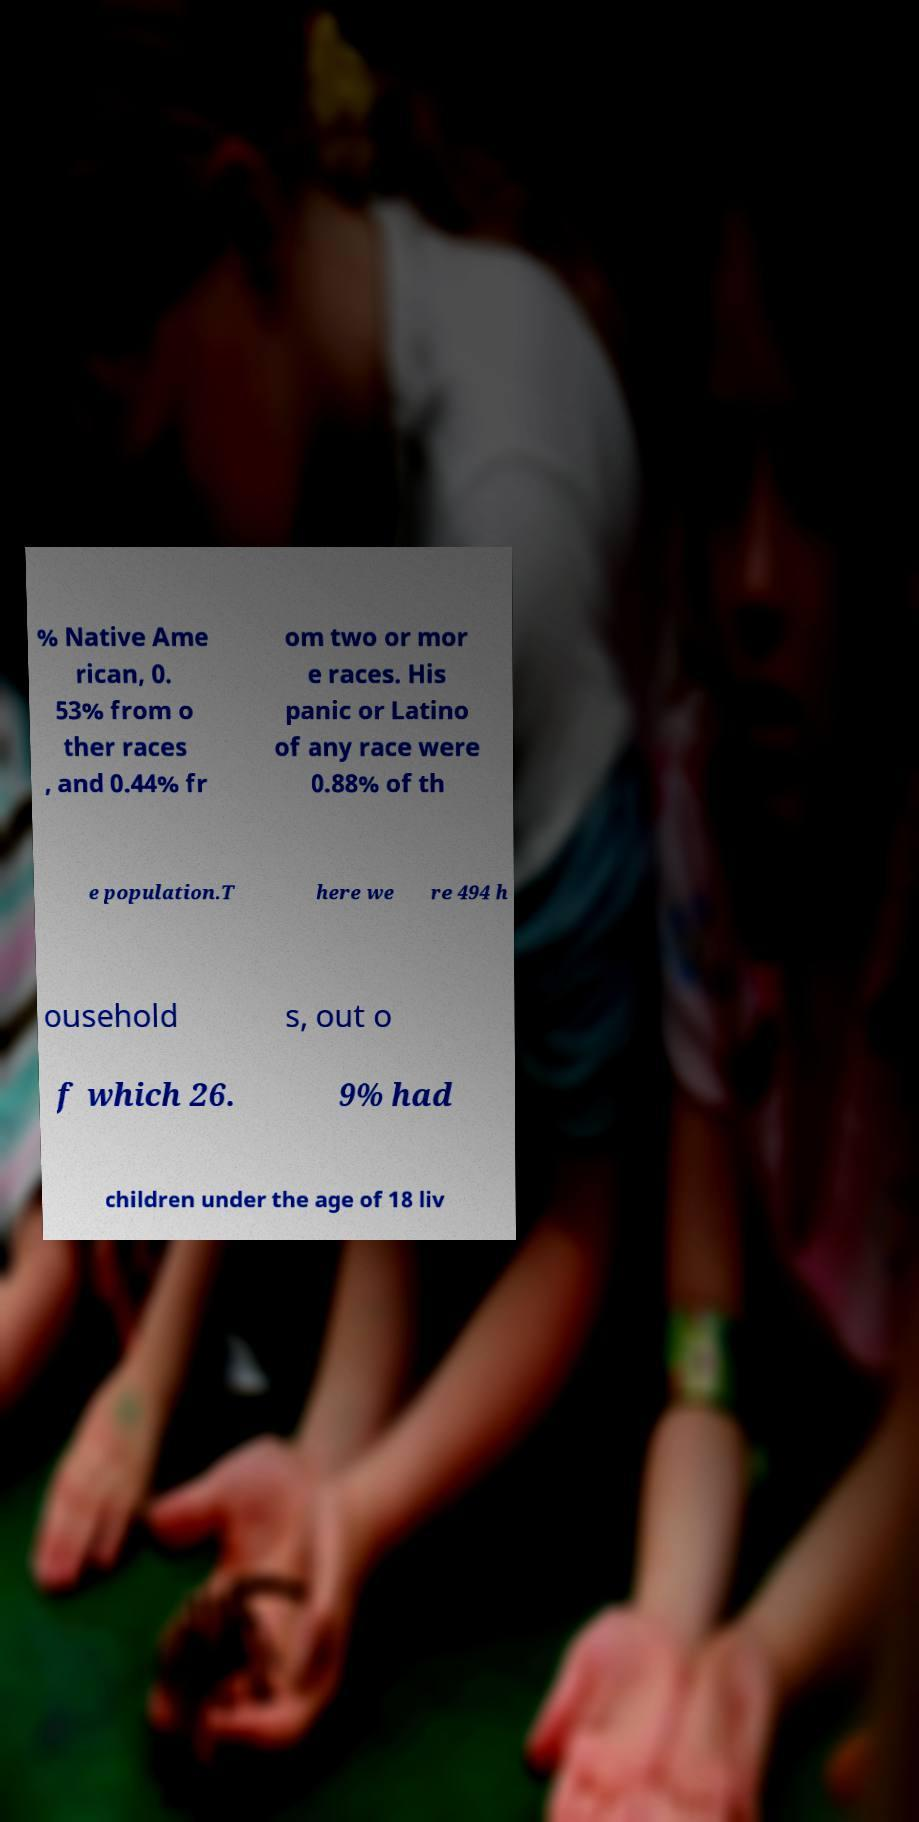Could you assist in decoding the text presented in this image and type it out clearly? % Native Ame rican, 0. 53% from o ther races , and 0.44% fr om two or mor e races. His panic or Latino of any race were 0.88% of th e population.T here we re 494 h ousehold s, out o f which 26. 9% had children under the age of 18 liv 